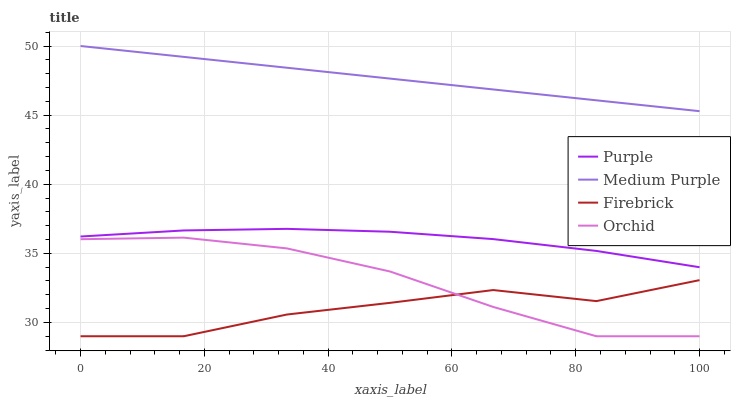Does Firebrick have the minimum area under the curve?
Answer yes or no. Yes. Does Medium Purple have the maximum area under the curve?
Answer yes or no. Yes. Does Medium Purple have the minimum area under the curve?
Answer yes or no. No. Does Firebrick have the maximum area under the curve?
Answer yes or no. No. Is Medium Purple the smoothest?
Answer yes or no. Yes. Is Firebrick the roughest?
Answer yes or no. Yes. Is Firebrick the smoothest?
Answer yes or no. No. Is Medium Purple the roughest?
Answer yes or no. No. Does Medium Purple have the lowest value?
Answer yes or no. No. Does Medium Purple have the highest value?
Answer yes or no. Yes. Does Firebrick have the highest value?
Answer yes or no. No. Is Firebrick less than Purple?
Answer yes or no. Yes. Is Medium Purple greater than Firebrick?
Answer yes or no. Yes. Does Firebrick intersect Purple?
Answer yes or no. No. 